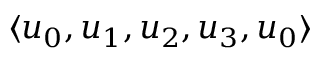<formula> <loc_0><loc_0><loc_500><loc_500>\langle u _ { 0 } , u _ { 1 } , u _ { 2 } , u _ { 3 } , u _ { 0 } \rangle</formula> 